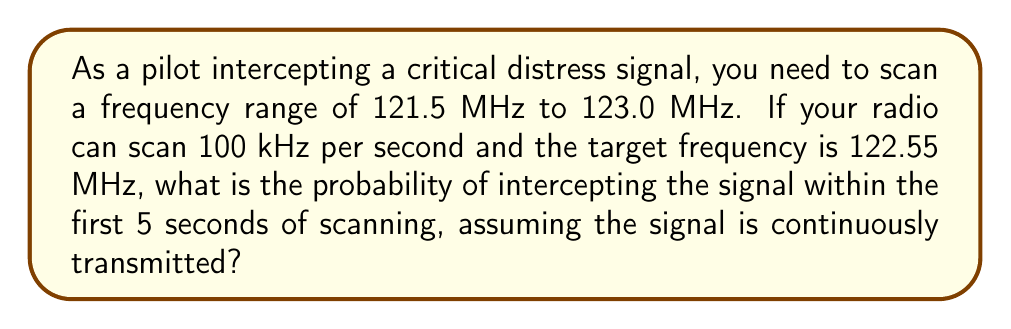Show me your answer to this math problem. Let's approach this step-by-step:

1) First, we need to calculate the total frequency range:
   $$123.0 \text{ MHz} - 121.5 \text{ MHz} = 1.5 \text{ MHz} = 1500 \text{ kHz}$$

2) The radio scans 100 kHz per second, so in 5 seconds it will scan:
   $$100 \text{ kHz/s} \times 5 \text{ s} = 500 \text{ kHz}$$

3) The probability of intercepting the signal is the ratio of the scanned range to the total range:
   $$P(\text{intercepting}) = \frac{\text{scanned range}}{\text{total range}} = \frac{500 \text{ kHz}}{1500 \text{ kHz}} = \frac{1}{3}$$

4) However, this assumes the scan starts at the beginning of the range. The target frequency (122.55 MHz) is actually 1050 kHz from the start of the range:
   $$122.55 \text{ MHz} - 121.5 \text{ MHz} = 1.05 \text{ MHz} = 1050 \text{ kHz}$$

5) For the signal to be intercepted within 5 seconds, the scan must start no earlier than:
   $$1050 \text{ kHz} - 500 \text{ kHz} = 550 \text{ kHz}$$ from the beginning of the range.

6) Therefore, the favorable range for starting the scan is:
   $$1500 \text{ kHz} - 550 \text{ kHz} = 950 \text{ kHz}$$

7) The probability is thus:
   $$P(\text{intercepting within 5s}) = \frac{950 \text{ kHz}}{1500 \text{ kHz}} = \frac{19}{30} \approx 0.6333$$
Answer: $\frac{19}{30}$ or approximately 0.6333 